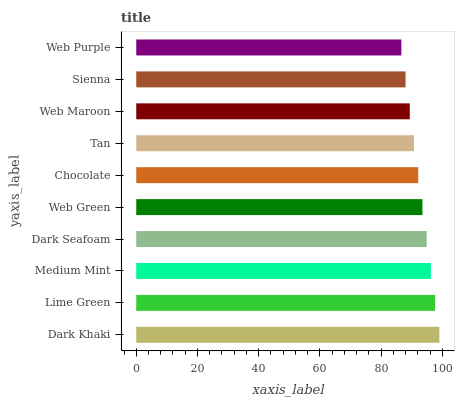Is Web Purple the minimum?
Answer yes or no. Yes. Is Dark Khaki the maximum?
Answer yes or no. Yes. Is Lime Green the minimum?
Answer yes or no. No. Is Lime Green the maximum?
Answer yes or no. No. Is Dark Khaki greater than Lime Green?
Answer yes or no. Yes. Is Lime Green less than Dark Khaki?
Answer yes or no. Yes. Is Lime Green greater than Dark Khaki?
Answer yes or no. No. Is Dark Khaki less than Lime Green?
Answer yes or no. No. Is Web Green the high median?
Answer yes or no. Yes. Is Chocolate the low median?
Answer yes or no. Yes. Is Sienna the high median?
Answer yes or no. No. Is Medium Mint the low median?
Answer yes or no. No. 